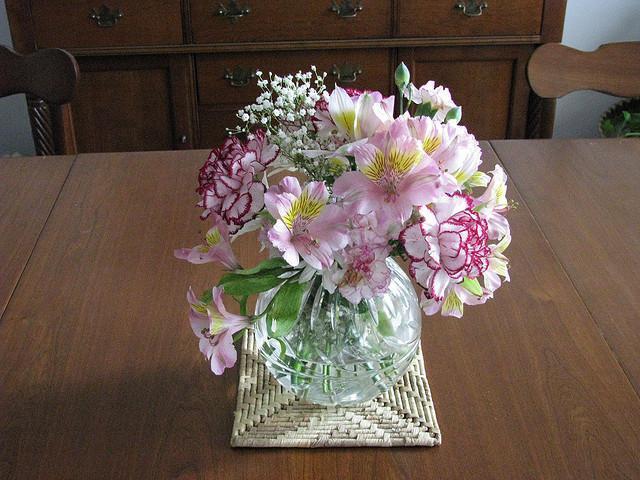How many chairs are in the image?
Give a very brief answer. 2. How many chairs are in the photo?
Give a very brief answer. 2. How many people are rowing?
Give a very brief answer. 0. 